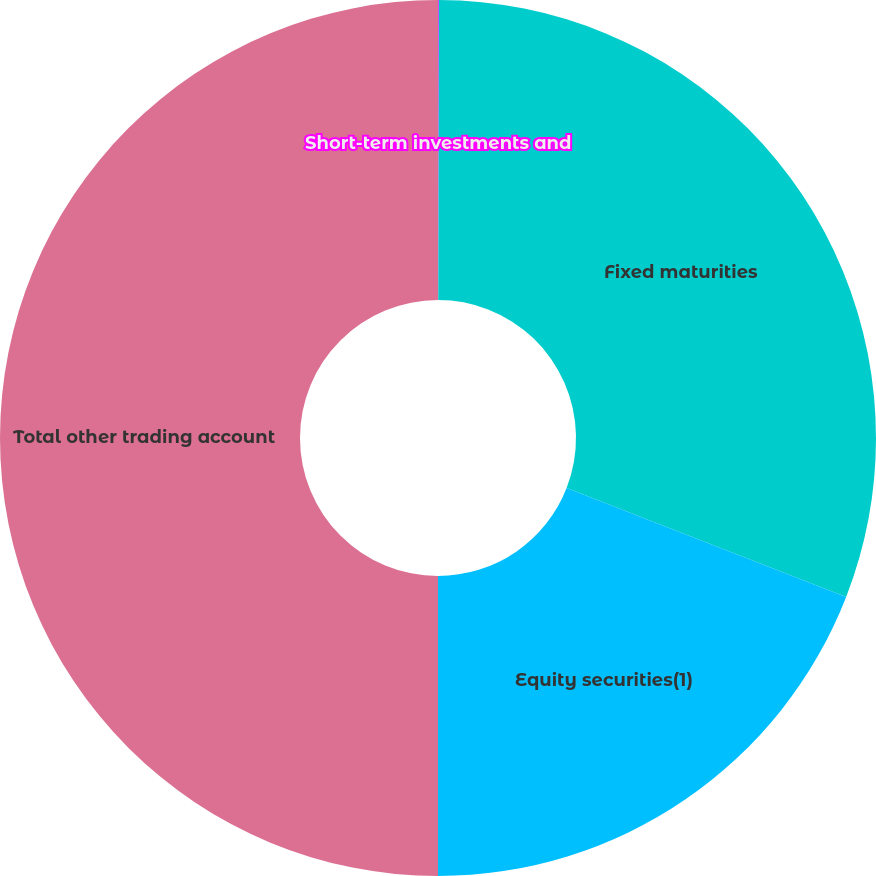Convert chart to OTSL. <chart><loc_0><loc_0><loc_500><loc_500><pie_chart><fcel>Short-term investments and<fcel>Fixed maturities<fcel>Equity securities(1)<fcel>Total other trading account<nl><fcel>0.03%<fcel>30.88%<fcel>19.09%<fcel>50.0%<nl></chart> 